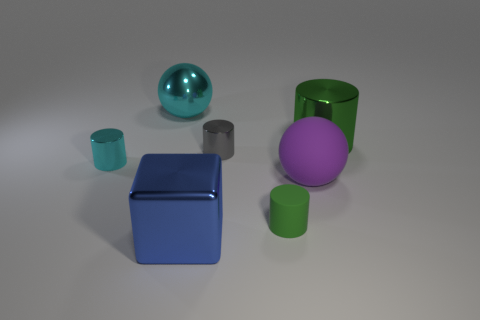Are there any other things that have the same color as the big metal sphere?
Provide a short and direct response. Yes. There is a small cyan object that is the same material as the large cylinder; what is its shape?
Offer a terse response. Cylinder. What is the material of the small thing that is on the right side of the metallic block and behind the purple matte ball?
Keep it short and to the point. Metal. Is there anything else that is the same size as the blue metallic object?
Give a very brief answer. Yes. Does the matte cylinder have the same color as the metallic block?
Give a very brief answer. No. What shape is the small matte object that is the same color as the large cylinder?
Your response must be concise. Cylinder. How many tiny rubber objects have the same shape as the green metallic thing?
Make the answer very short. 1. There is a gray cylinder that is made of the same material as the big blue block; what size is it?
Ensure brevity in your answer.  Small. Do the cyan shiny ball and the purple thing have the same size?
Provide a short and direct response. Yes. Are any large green metallic objects visible?
Your answer should be compact. Yes. 